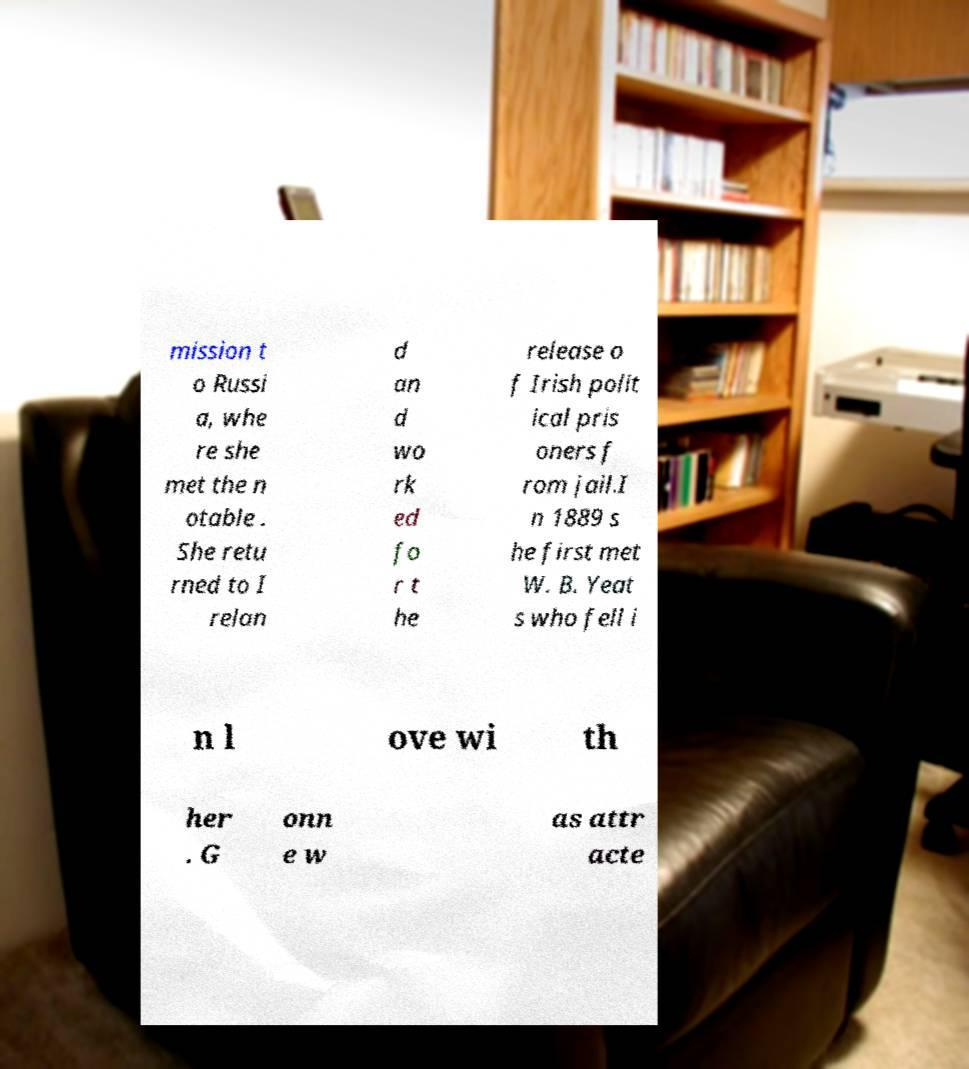Can you accurately transcribe the text from the provided image for me? mission t o Russi a, whe re she met the n otable . She retu rned to I relan d an d wo rk ed fo r t he release o f Irish polit ical pris oners f rom jail.I n 1889 s he first met W. B. Yeat s who fell i n l ove wi th her . G onn e w as attr acte 